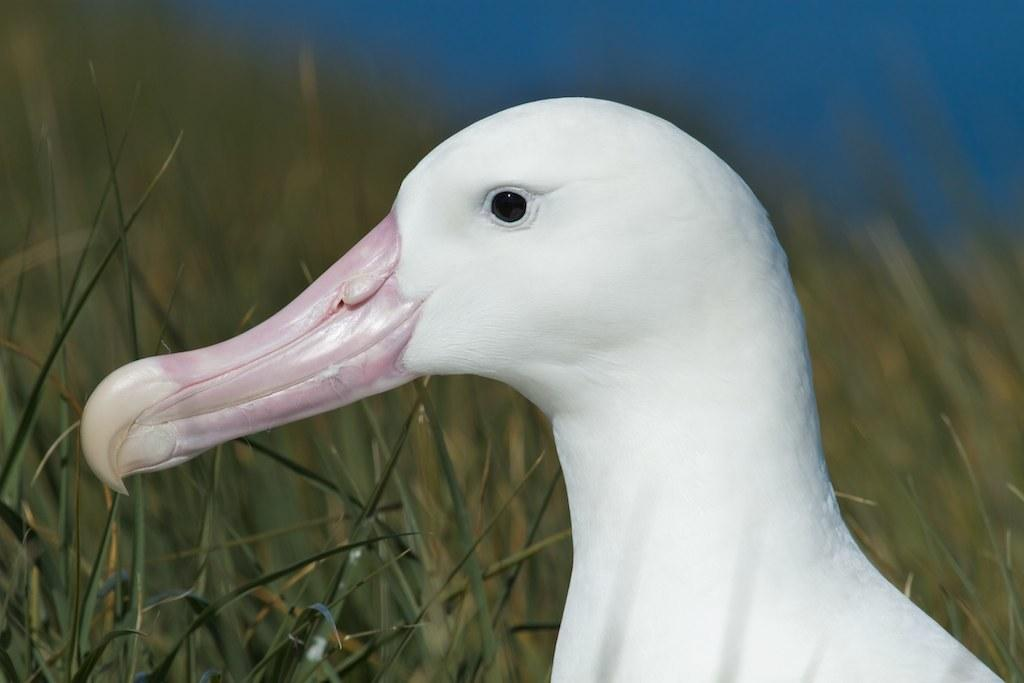What type of animal is present in the image? There is a bird in the image. What type of vegetation can be seen in the image? There is grass in the image. How would you describe the background of the image? The background of the image is blurry. What type of fruit is hanging from the bird's beak in the image? There is no fruit present in the image, and the bird's beak is not shown to be holding anything. 